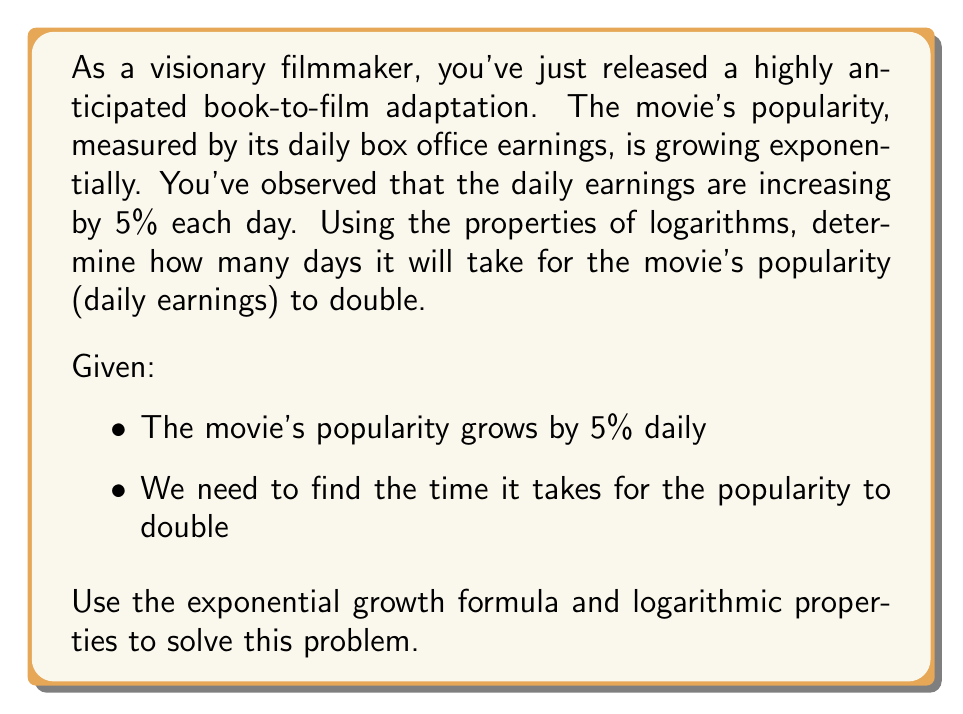Can you answer this question? Let's approach this step-by-step:

1) The exponential growth formula is:
   $$A = P(1 + r)^t$$
   Where:
   $A$ = Final amount
   $P$ = Initial amount
   $r$ = Growth rate (as a decimal)
   $t$ = Time

2) We want to find when the popularity doubles, so:
   $$2P = P(1 + 0.05)^t$$

3) Simplify by dividing both sides by $P$:
   $$2 = (1.05)^t$$

4) Take the natural logarithm of both sides:
   $$\ln(2) = \ln((1.05)^t)$$

5) Use the logarithm property $\ln(a^b) = b\ln(a)$:
   $$\ln(2) = t\ln(1.05)$$

6) Solve for $t$ by dividing both sides by $\ln(1.05)$:
   $$t = \frac{\ln(2)}{\ln(1.05)}$$

7) Calculate the result:
   $$t \approx 14.2067$$

8) Since we can't have a fractional day, we round up to the next whole day.
Answer: It will take 15 days for the movie's popularity (daily earnings) to double. 